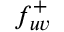<formula> <loc_0><loc_0><loc_500><loc_500>f _ { u v } ^ { + }</formula> 